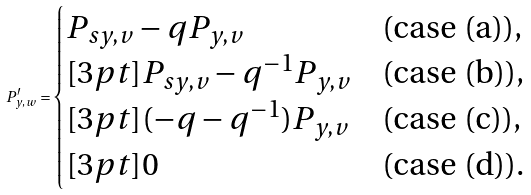<formula> <loc_0><loc_0><loc_500><loc_500>P ^ { \prime } _ { y , w } = \begin{cases} P _ { s y , v } - q P _ { y , v } & \text {(case (a)),} \\ [ 3 p t ] P _ { s y , v } - q ^ { - 1 } P _ { y , v } & \text {(case (b)),} \\ [ 3 p t ] ( - q - q ^ { - 1 } ) P _ { y , v } & \text {(case (c)),} \\ [ 3 p t ] 0 & \text {(case (d)).} \end{cases}</formula> 